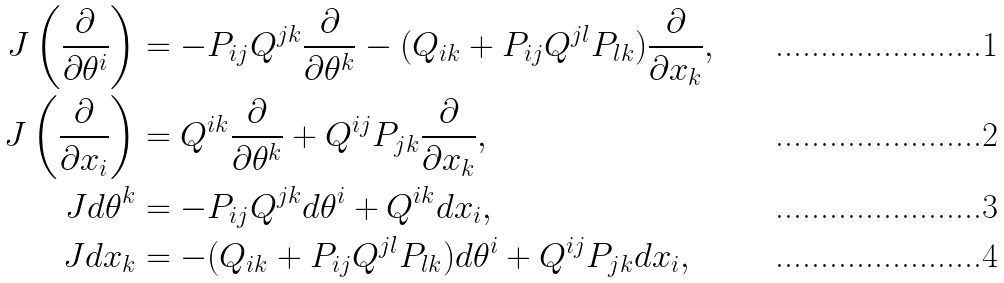Convert formula to latex. <formula><loc_0><loc_0><loc_500><loc_500>J \left ( \frac { \partial } { \partial \theta ^ { i } } \right ) & = - P _ { i j } Q ^ { j k } \frac { \partial } { \partial \theta ^ { k } } - ( Q _ { i k } + P _ { i j } Q ^ { j l } P _ { l k } ) \frac { \partial } { \partial x _ { k } } , \\ J \left ( \frac { \partial } { \partial x _ { i } } \right ) & = Q ^ { i k } \frac { \partial } { \partial \theta ^ { k } } + Q ^ { i j } P _ { j k } \frac { \partial } { \partial x _ { k } } , \\ J d \theta ^ { k } & = - P _ { i j } Q ^ { j k } d \theta ^ { i } + Q ^ { i k } d x _ { i } , \\ J d x _ { k } & = - ( Q _ { i k } + P _ { i j } Q ^ { j l } P _ { l k } ) d \theta ^ { i } + Q ^ { i j } P _ { j k } d x _ { i } ,</formula> 